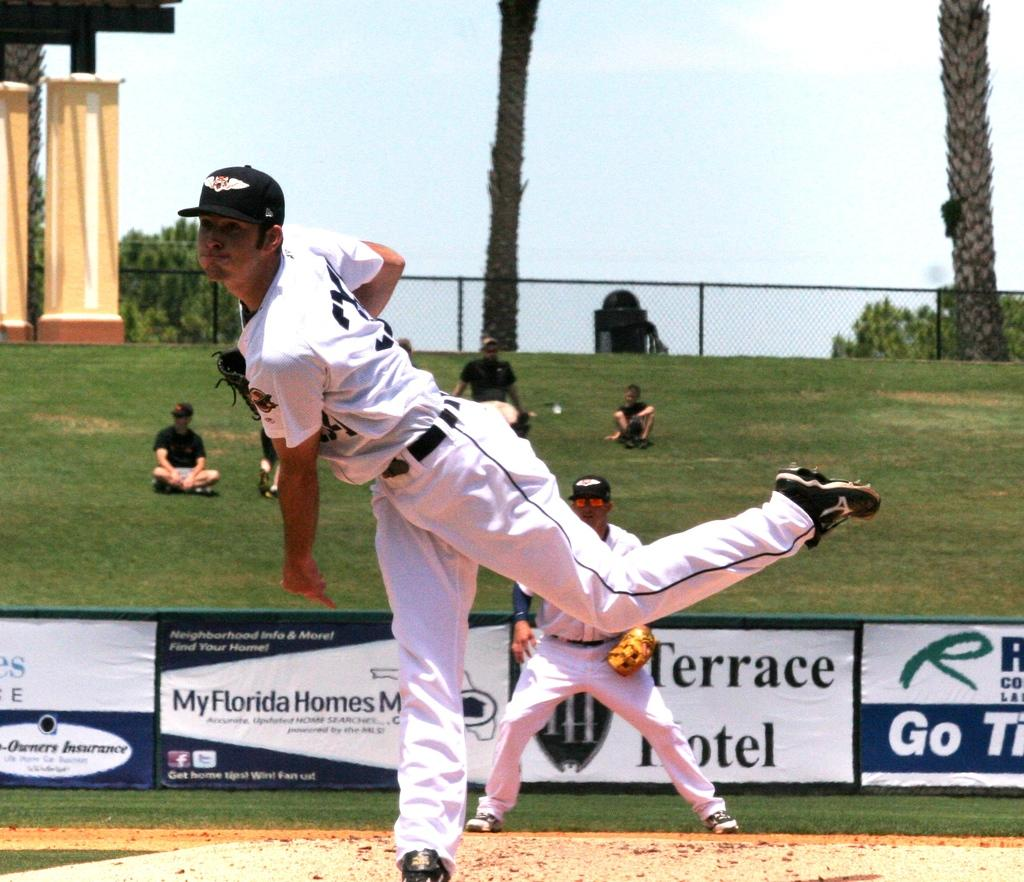<image>
Create a compact narrative representing the image presented. A man in white plays sports in front of an advert for Terrace Hotel. 